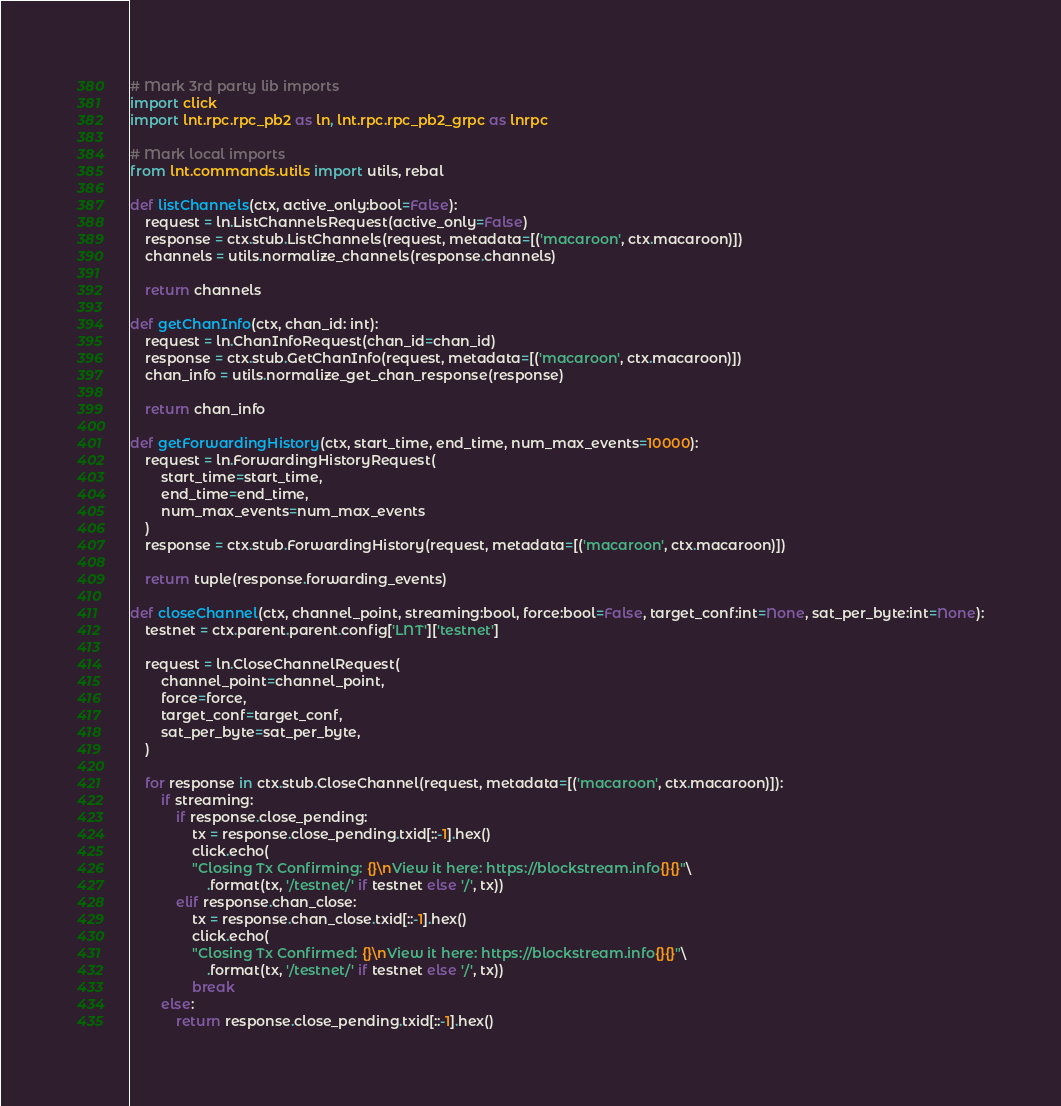Convert code to text. <code><loc_0><loc_0><loc_500><loc_500><_Python_># Mark 3rd party lib imports
import click
import lnt.rpc.rpc_pb2 as ln, lnt.rpc.rpc_pb2_grpc as lnrpc

# Mark local imports
from lnt.commands.utils import utils, rebal

def listChannels(ctx, active_only:bool=False):
    request = ln.ListChannelsRequest(active_only=False)
    response = ctx.stub.ListChannels(request, metadata=[('macaroon', ctx.macaroon)])
    channels = utils.normalize_channels(response.channels)

    return channels

def getChanInfo(ctx, chan_id: int):
    request = ln.ChanInfoRequest(chan_id=chan_id)
    response = ctx.stub.GetChanInfo(request, metadata=[('macaroon', ctx.macaroon)])
    chan_info = utils.normalize_get_chan_response(response)

    return chan_info

def getForwardingHistory(ctx, start_time, end_time, num_max_events=10000):
    request = ln.ForwardingHistoryRequest(
        start_time=start_time,
        end_time=end_time,
        num_max_events=num_max_events
    )
    response = ctx.stub.ForwardingHistory(request, metadata=[('macaroon', ctx.macaroon)])

    return tuple(response.forwarding_events)

def closeChannel(ctx, channel_point, streaming:bool, force:bool=False, target_conf:int=None, sat_per_byte:int=None):
    testnet = ctx.parent.parent.config['LNT']['testnet']

    request = ln.CloseChannelRequest(
        channel_point=channel_point,
        force=force,
        target_conf=target_conf,
        sat_per_byte=sat_per_byte,
    )

    for response in ctx.stub.CloseChannel(request, metadata=[('macaroon', ctx.macaroon)]):
        if streaming:
            if response.close_pending:
                tx = response.close_pending.txid[::-1].hex()
                click.echo(
                "Closing Tx Confirming: {}\nView it here: https://blockstream.info{}{}"\
                    .format(tx, '/testnet/' if testnet else '/', tx))
            elif response.chan_close:
                tx = response.chan_close.txid[::-1].hex()
                click.echo(
                "Closing Tx Confirmed: {}\nView it here: https://blockstream.info{}{}"\
                    .format(tx, '/testnet/' if testnet else '/', tx))
                break
        else:
            return response.close_pending.txid[::-1].hex()</code> 